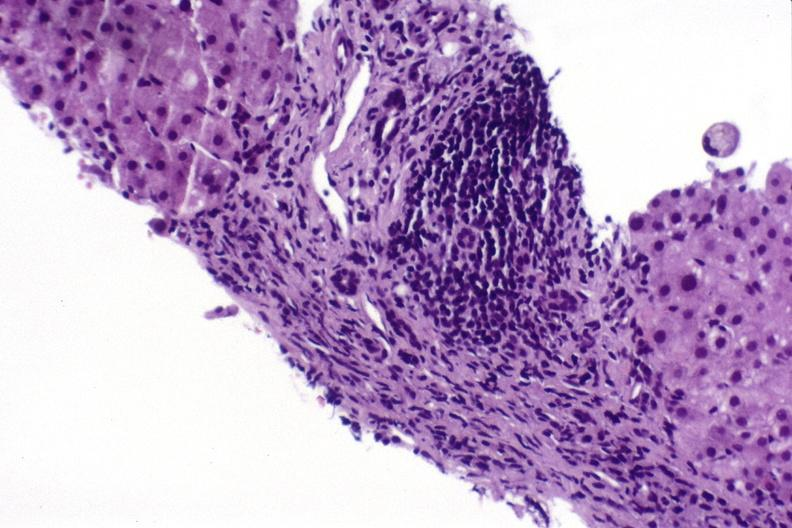s gangrene toe in infant present?
Answer the question using a single word or phrase. No 